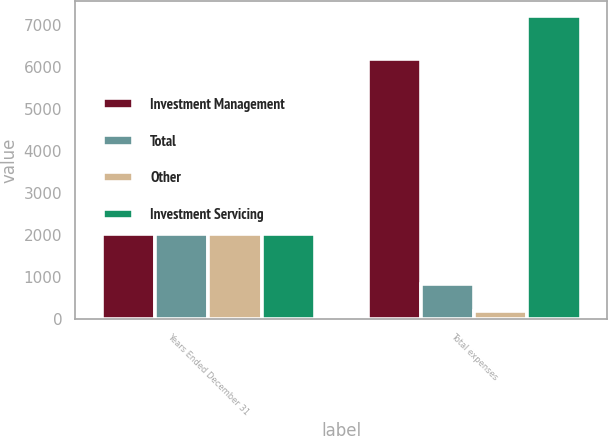Convert chart. <chart><loc_0><loc_0><loc_500><loc_500><stacked_bar_chart><ecel><fcel>Years Ended December 31<fcel>Total expenses<nl><fcel>Investment Management<fcel>2013<fcel>6176<nl><fcel>Total<fcel>2013<fcel>836<nl><fcel>Other<fcel>2013<fcel>180<nl><fcel>Investment Servicing<fcel>2013<fcel>7192<nl></chart> 